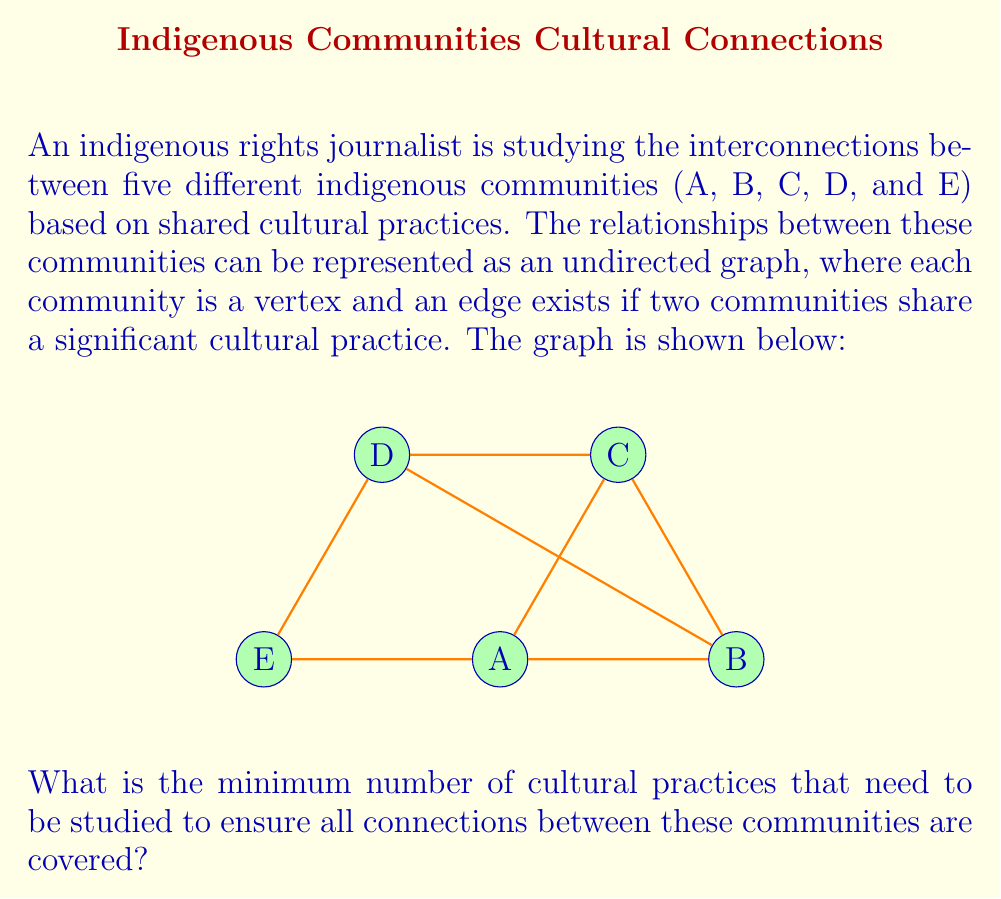Give your solution to this math problem. To solve this problem, we need to find the minimum edge cover of the given graph. An edge cover is a set of edges such that every vertex in the graph is incident to at least one edge in the set. The minimum edge cover is the smallest such set.

Let's approach this step-by-step:

1) First, we need to identify the number of vertices and edges in the graph:
   - There are 5 vertices (A, B, C, D, E)
   - There are 7 edges (A-B, A-C, A-E, B-C, B-D, C-D, D-E)

2) In graph theory, there's a theorem that states: the size of a minimum edge cover is equal to $max(n/2, m)$, where $n$ is the number of vertices and $m$ is the size of a maximum matching.

3) To find the maximum matching:
   - A-B, C-D, E is a matching of size 3
   - This is maximum because no larger matching is possible

4) Now we can apply the theorem:
   $max(n/2, m) = max(5/2, 3) = max(2.5, 3) = 3$

Therefore, the minimum edge cover has size 3.

5) One possible minimum edge cover is: A-C, B-D, D-E
   This covers all vertices with just 3 edges.

Each edge in our graph represents a shared cultural practice. So, the minimum number of cultural practices we need to study to cover all connections is equal to the size of the minimum edge cover.
Answer: 3 